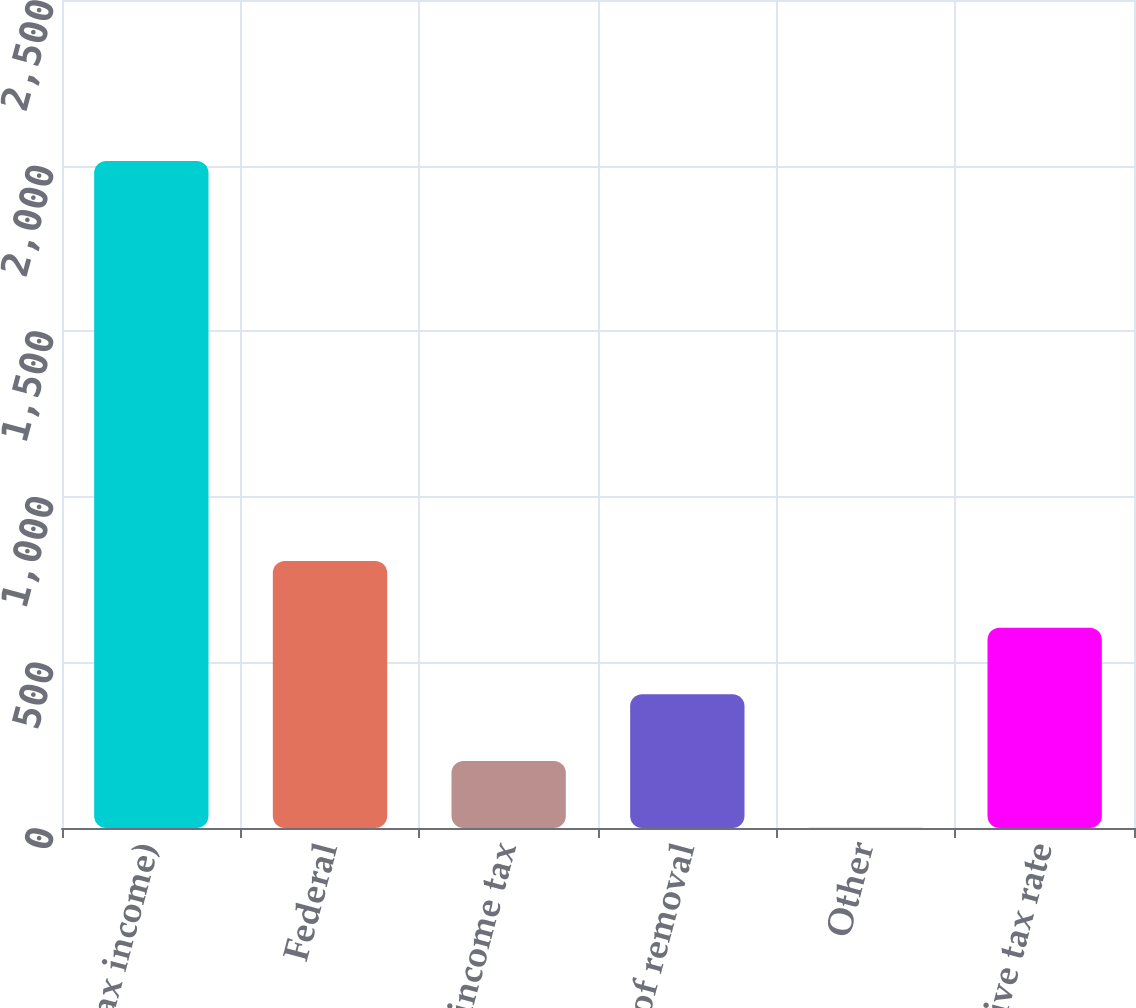Convert chart to OTSL. <chart><loc_0><loc_0><loc_500><loc_500><bar_chart><fcel>( of Pre-tax income)<fcel>Federal<fcel>State income tax<fcel>Cost of removal<fcel>Other<fcel>Effective tax rate<nl><fcel>2014<fcel>806.2<fcel>202.3<fcel>403.6<fcel>1<fcel>604.9<nl></chart> 